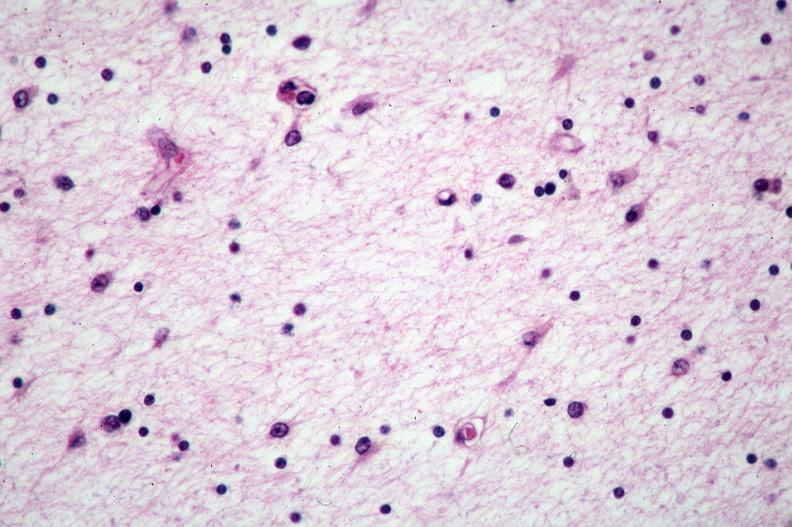where is this?
Answer the question using a single word or phrase. Nervous 